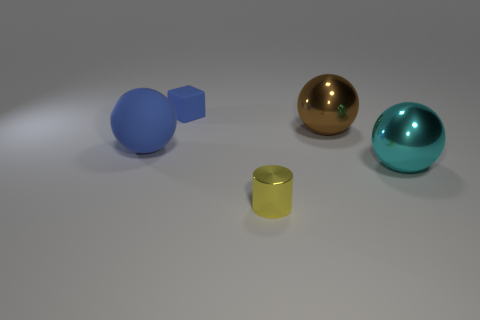What color is the thing that is the same material as the big blue sphere?
Your response must be concise. Blue. Is there a cube that has the same size as the cyan metal ball?
Make the answer very short. No. There is a brown object that is the same shape as the big blue thing; what is it made of?
Provide a short and direct response. Metal. There is a blue object that is the same size as the yellow object; what shape is it?
Provide a short and direct response. Cube. Is there a large object that has the same shape as the small yellow object?
Make the answer very short. No. What is the shape of the blue thing in front of the blue object that is to the right of the blue ball?
Give a very brief answer. Sphere. The small yellow metallic thing is what shape?
Give a very brief answer. Cylinder. The blue thing that is on the right side of the blue matte object that is on the left side of the matte object that is on the right side of the matte ball is made of what material?
Give a very brief answer. Rubber. What number of other things are there of the same material as the large blue thing
Offer a terse response. 1. There is a metallic sphere on the right side of the big brown shiny object; how many brown shiny things are behind it?
Offer a very short reply. 1. 